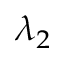<formula> <loc_0><loc_0><loc_500><loc_500>\lambda _ { 2 }</formula> 